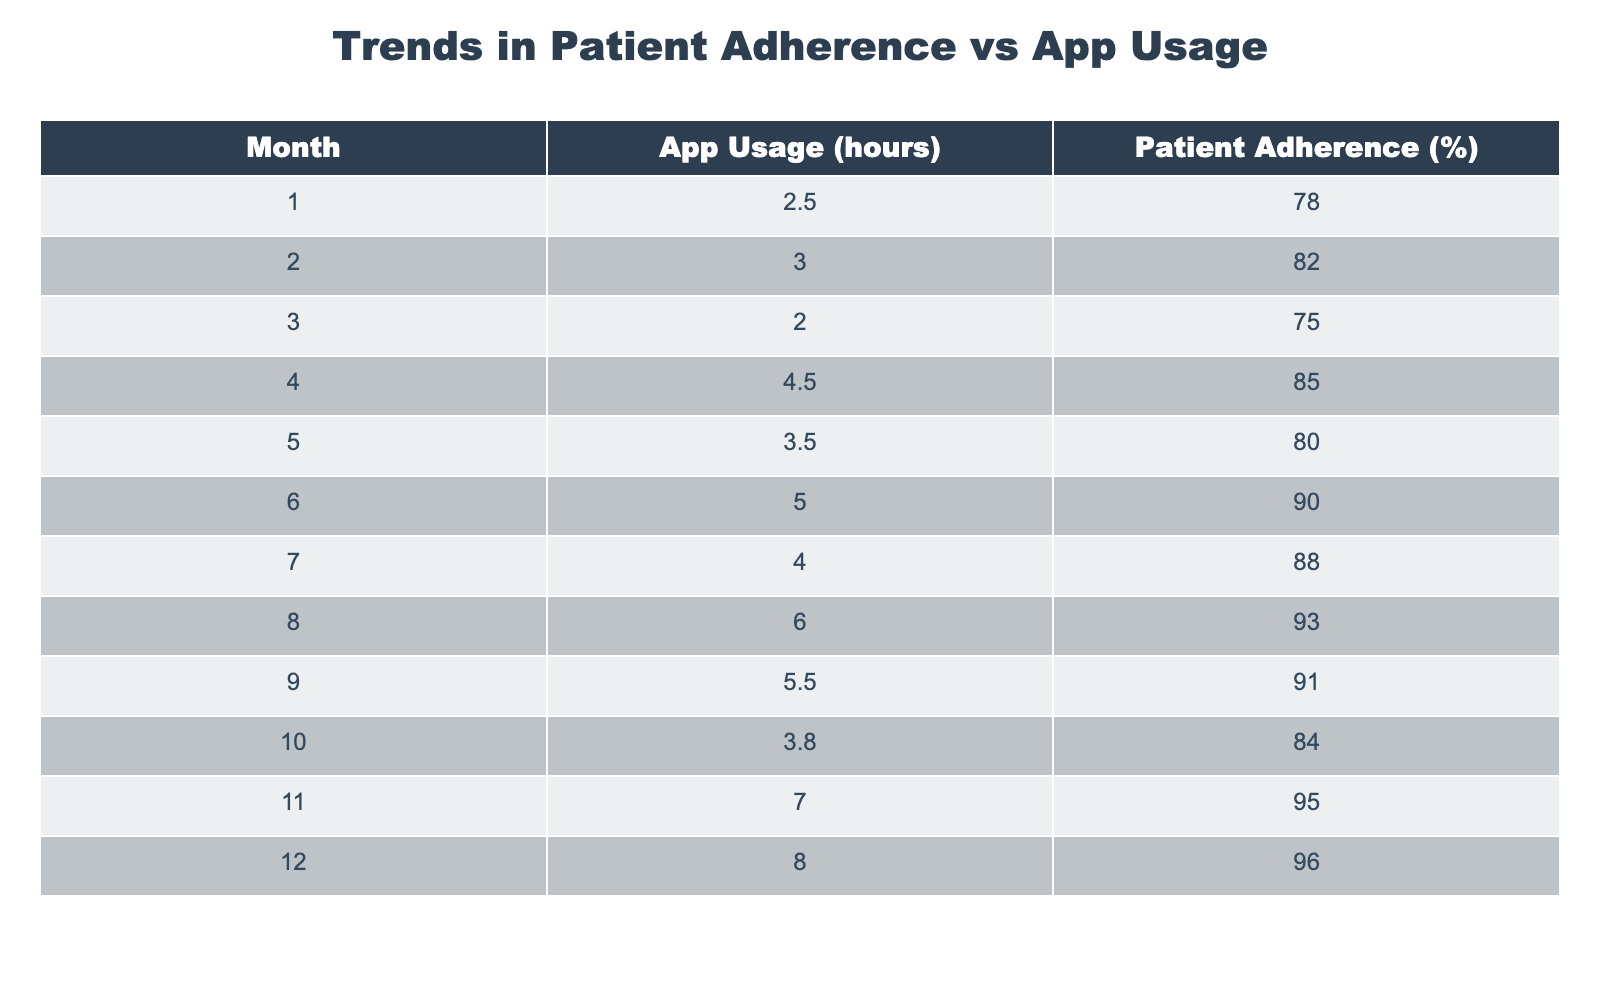What is the patient adherence percentage in the 6th month? From the table, looking at the row for month 6, the patient adherence percentage is directly listed as 90%.
Answer: 90% What month had the highest app usage and what was that usage? The highest app usage is in month 12, where it is noted as 8.0 hours.
Answer: 8.0 hours What is the average patient adherence percentage over the 12 months? Adding all the adherence percentages together (78 + 82 + 75 + 85 + 80 + 90 + 88 + 93 + 91 + 84 + 95 + 96) gives a total of 1,022. Dividing this total by 12 months gives an average of approximately 85.17%.
Answer: 85.17% Was there any month where patient adherence was above 90%? Looking through the table, patient adherence exceeds 90% in months 6, 8, 11, and 12. Yes, there were months where adherence was above 90%.
Answer: Yes What was the change in patient adherence from month 4 to month 8? Month 4 had an adherence percentage of 85%, and month 8 had an adherence percentage of 93%. The change is 93 - 85 = 8%.
Answer: 8% Which month had a decrease in patient adherence compared to the previous month? Reviewing the table, month 10 (84%) shows a decrease from month 9 (91%). Hence, month 10 had a decrease.
Answer: Month 10 What is the total app usage for the first half of the year? Summing the app usage from months 1 to 6 gives (2.5 + 3.0 + 2.0 + 4.5 + 3.5 + 5.0) = 20 hours total for the first six months.
Answer: 20 hours Is there a positive correlation between app usage and patient adherence throughout the year? By examining the trend, we can see that as app usage tends to increase (from 2.5 to 8.0 hours), patient adherence also generally increases (from 78% to 96%). Thus, there appears to be a positive correlation.
Answer: Yes 